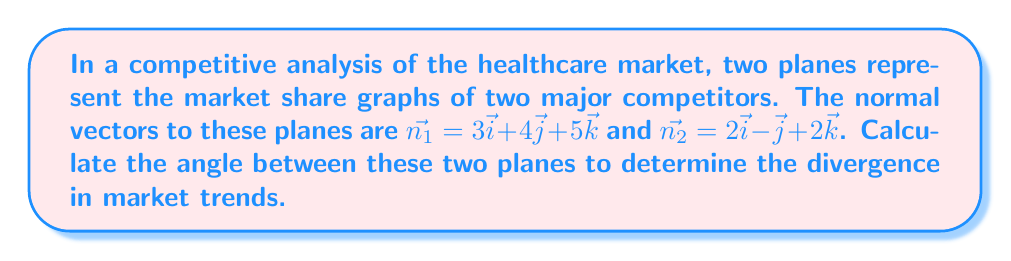Can you solve this math problem? To find the angle between two planes, we need to calculate the angle between their normal vectors. We can use the dot product formula:

$$\cos \theta = \frac{\vec{n_1} \cdot \vec{n_2}}{|\vec{n_1}| |\vec{n_2}|}$$

Step 1: Calculate the dot product $\vec{n_1} \cdot \vec{n_2}$
$$\vec{n_1} \cdot \vec{n_2} = (3)(2) + (4)(-1) + (5)(2) = 6 - 4 + 10 = 12$$

Step 2: Calculate the magnitudes of the vectors
$$|\vec{n_1}| = \sqrt{3^2 + 4^2 + 5^2} = \sqrt{50}$$
$$|\vec{n_2}| = \sqrt{2^2 + (-1)^2 + 2^2} = \sqrt{9} = 3$$

Step 3: Substitute into the formula
$$\cos \theta = \frac{12}{\sqrt{50} \cdot 3}$$

Step 4: Simplify
$$\cos \theta = \frac{12}{3\sqrt{50}} = \frac{4}{\sqrt{50}} = \frac{4\sqrt{2}}{\sqrt{100}} = \frac{4\sqrt{2}}{10} = \frac{2\sqrt{2}}{5}$$

Step 5: Take the inverse cosine (arccos) of both sides
$$\theta = \arccos(\frac{2\sqrt{2}}{5})$$

Step 6: Convert to degrees
$$\theta \approx 53.13^\circ$$
Answer: $53.13^\circ$ 